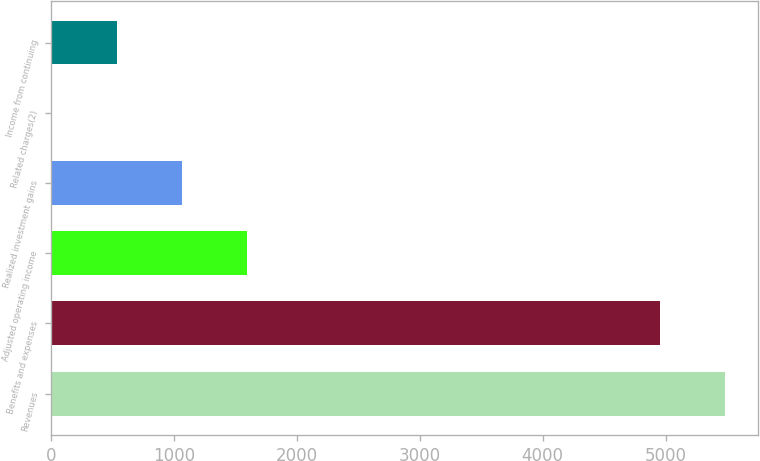<chart> <loc_0><loc_0><loc_500><loc_500><bar_chart><fcel>Revenues<fcel>Benefits and expenses<fcel>Adjusted operating income<fcel>Realized investment gains<fcel>Related charges(2)<fcel>Income from continuing<nl><fcel>5481.8<fcel>4954<fcel>1590.4<fcel>1062.6<fcel>7<fcel>534.8<nl></chart> 